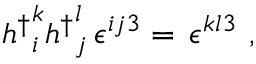<formula> <loc_0><loc_0><loc_500><loc_500>{ h ^ { \dagger } } _ { i } ^ { k } { h ^ { \dagger } } _ { j } ^ { l } \, \epsilon ^ { i j 3 } = \, \epsilon ^ { k l 3 } \ ,</formula> 